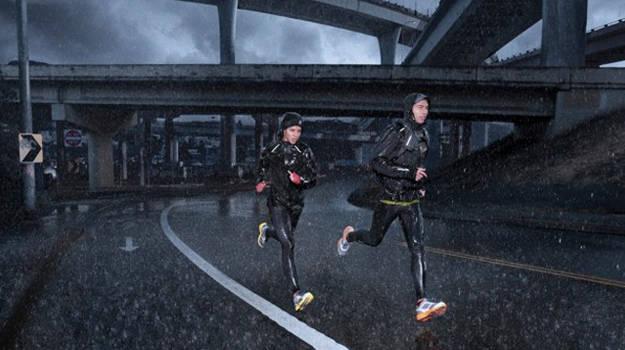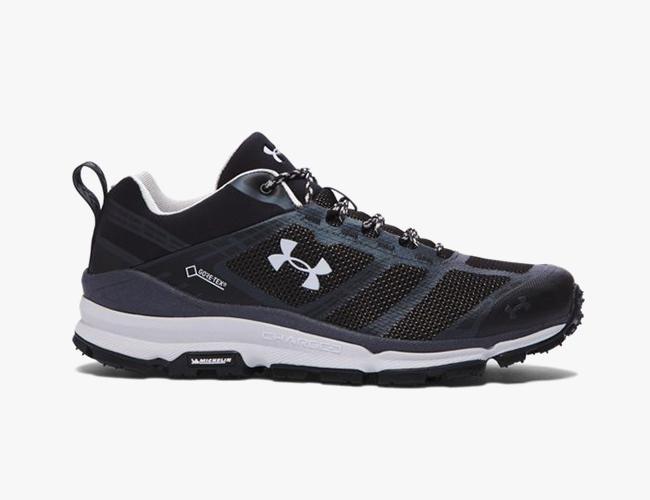The first image is the image on the left, the second image is the image on the right. Given the left and right images, does the statement "There is an image of a single shoe pointing to the right." hold true? Answer yes or no. Yes. The first image is the image on the left, the second image is the image on the right. Given the left and right images, does the statement "There are two people running on the pavement." hold true? Answer yes or no. Yes. 